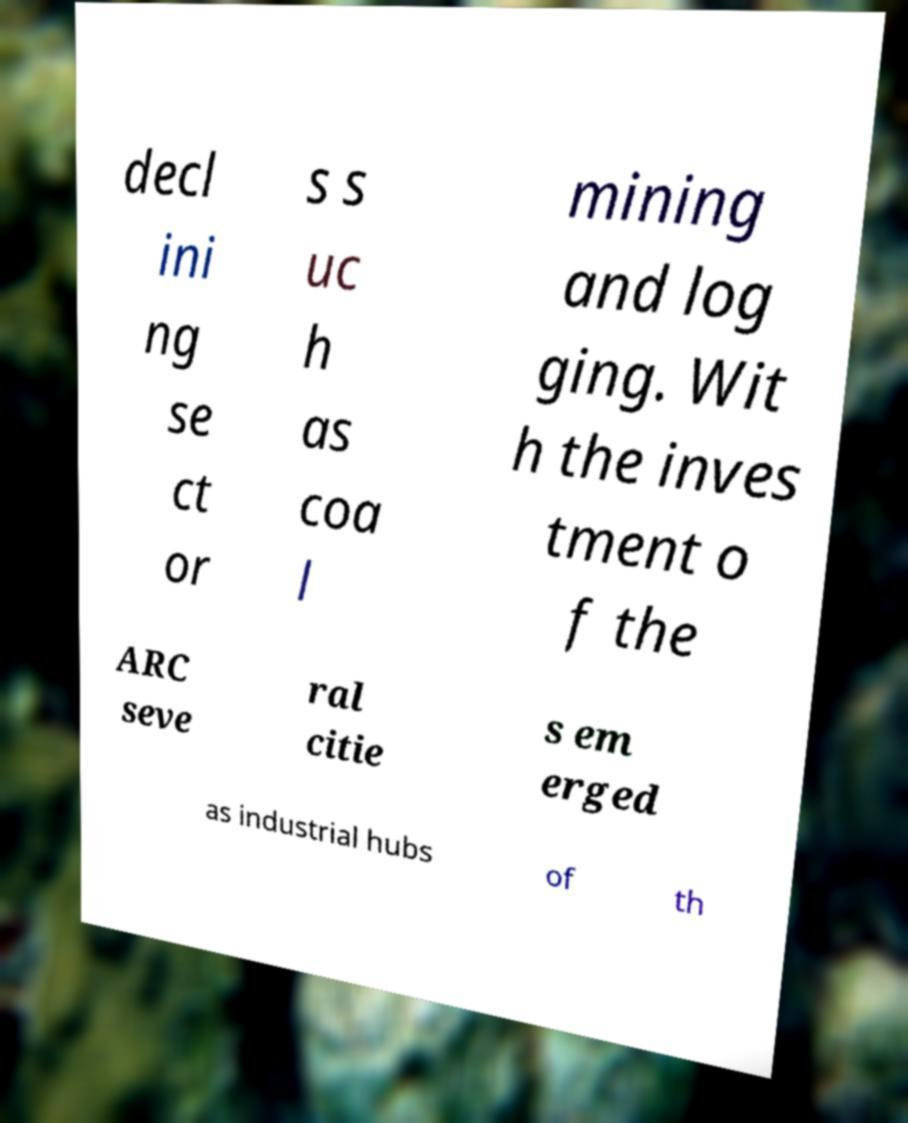What messages or text are displayed in this image? I need them in a readable, typed format. decl ini ng se ct or s s uc h as coa l mining and log ging. Wit h the inves tment o f the ARC seve ral citie s em erged as industrial hubs of th 